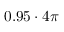Convert formula to latex. <formula><loc_0><loc_0><loc_500><loc_500>0 . 9 5 \cdot 4 \pi</formula> 